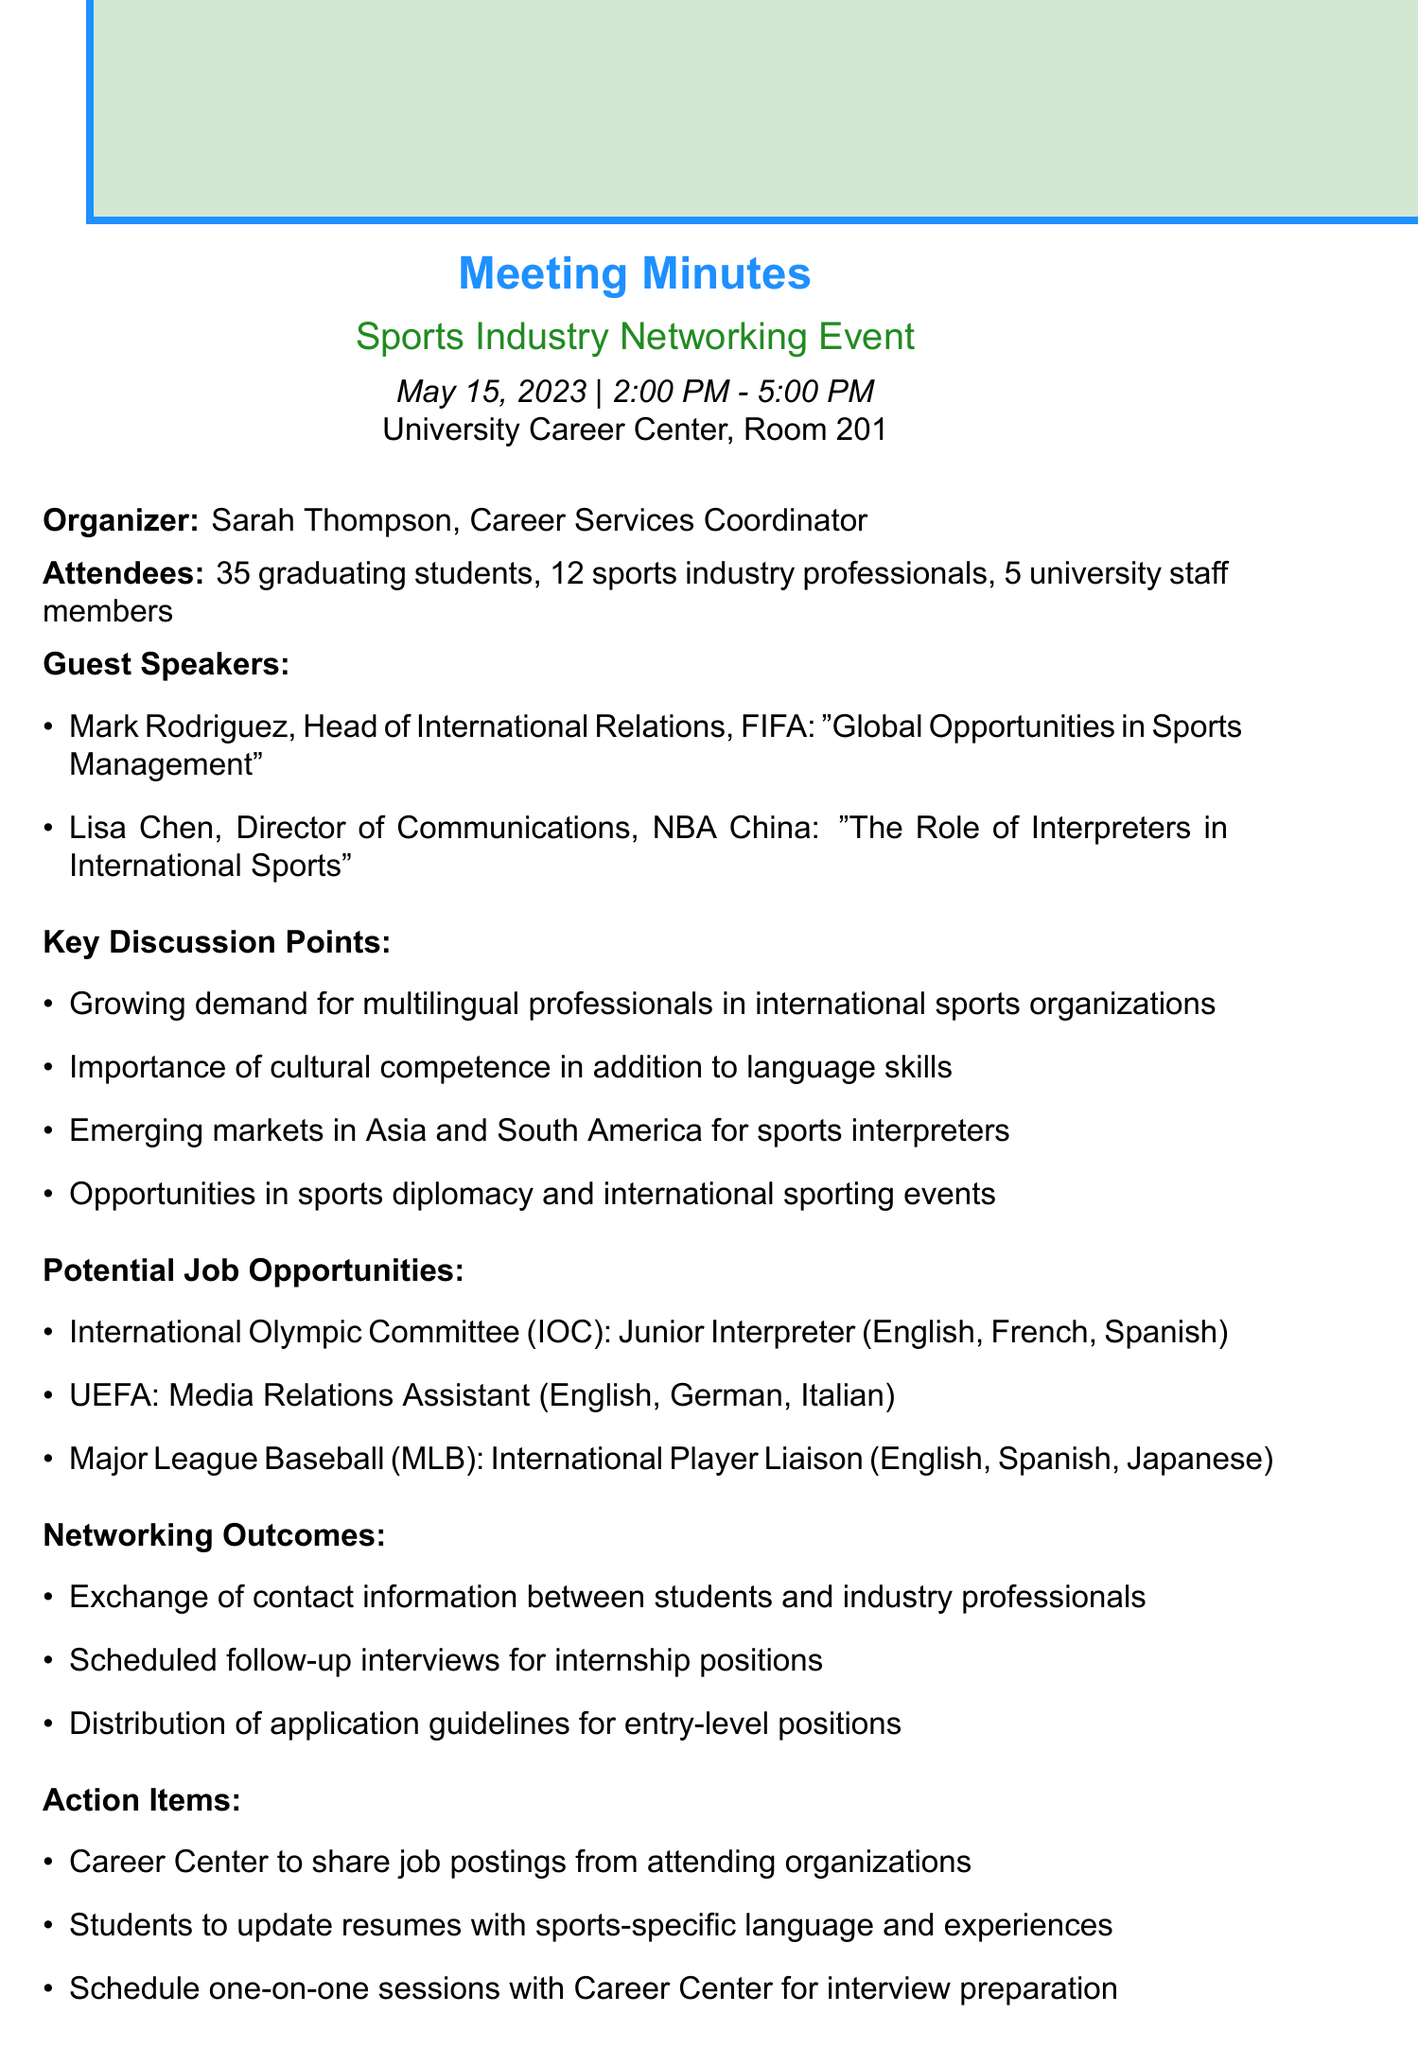what was the date of the event? The date of the event is explicitly stated in the document as May 15, 2023.
Answer: May 15, 2023 who organized the Sports Industry Networking Event? The organizer of the event is mentioned in the document as Sarah Thompson, Career Services Coordinator.
Answer: Sarah Thompson how many sports industry professionals attended? The document specifies that there were 12 sports industry professionals in attendance.
Answer: 12 what is one key discussion point highlighted in the meeting? The document lists several key discussion points, one of which is the growing demand for multilingual professionals in international sports organizations.
Answer: Growing demand for multilingual professionals which organization is hiring a Junior Interpreter? The document clearly states that the International Olympic Committee (IOC) is hiring a Junior Interpreter.
Answer: International Olympic Committee (IOC) what was one of the networking outcomes listed? The document describes several outcomes, including the exchange of contact information between students and industry professionals.
Answer: Exchange of contact information how many job opportunities were listed in the document? The document provides three specific job opportunities in the sports industry.
Answer: 3 what action item involves updating resumes? The document states that students are to update resumes with sports-specific language and experiences.
Answer: Update resumes with sports-specific language and experiences 